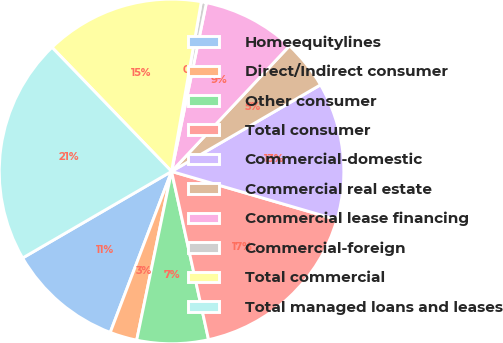Convert chart to OTSL. <chart><loc_0><loc_0><loc_500><loc_500><pie_chart><fcel>Homeequitylines<fcel>Direct/Indirect consumer<fcel>Other consumer<fcel>Total consumer<fcel>Commercial-domestic<fcel>Commercial real estate<fcel>Commercial lease financing<fcel>Commercial-foreign<fcel>Total commercial<fcel>Total managed loans and leases<nl><fcel>10.83%<fcel>2.55%<fcel>6.69%<fcel>17.04%<fcel>12.9%<fcel>4.62%<fcel>8.76%<fcel>0.48%<fcel>14.97%<fcel>21.18%<nl></chart> 